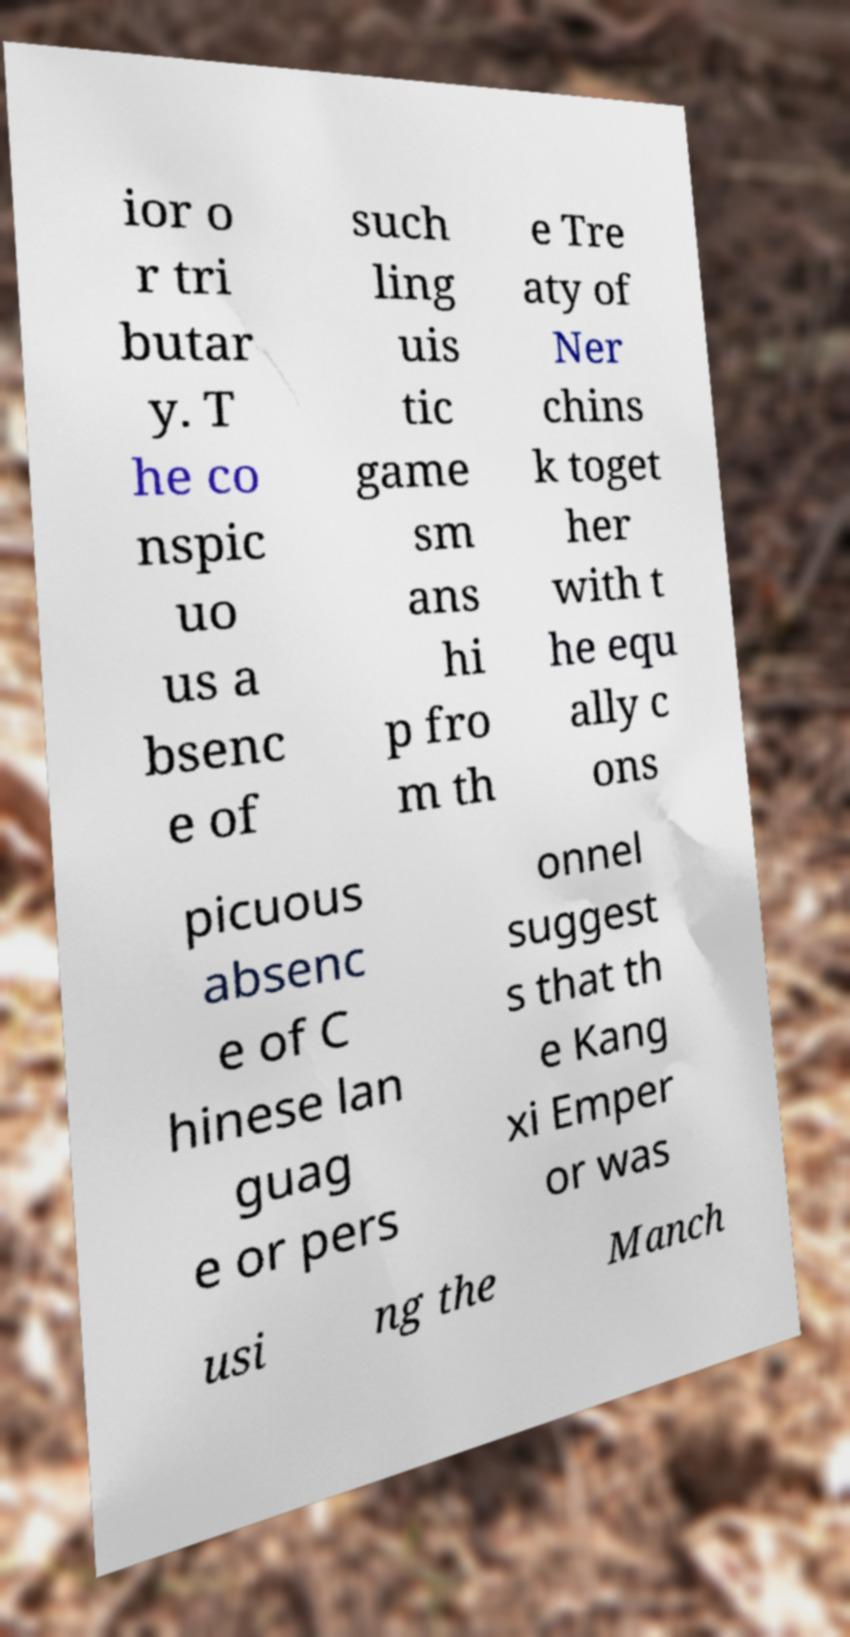What messages or text are displayed in this image? I need them in a readable, typed format. ior o r tri butar y. T he co nspic uo us a bsenc e of such ling uis tic game sm ans hi p fro m th e Tre aty of Ner chins k toget her with t he equ ally c ons picuous absenc e of C hinese lan guag e or pers onnel suggest s that th e Kang xi Emper or was usi ng the Manch 